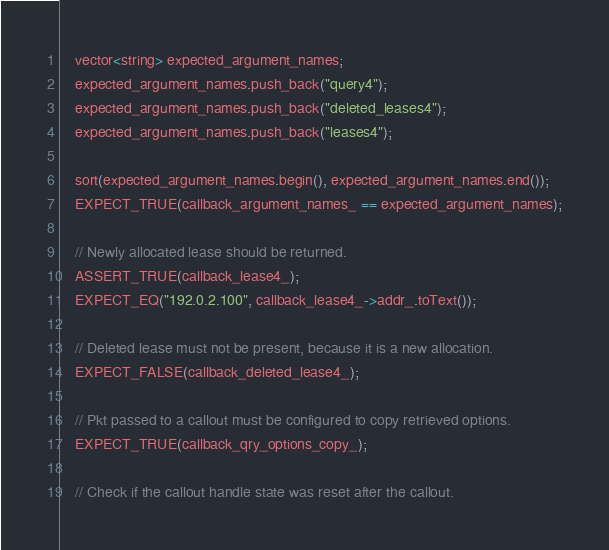Convert code to text. <code><loc_0><loc_0><loc_500><loc_500><_C++_>    vector<string> expected_argument_names;
    expected_argument_names.push_back("query4");
    expected_argument_names.push_back("deleted_leases4");
    expected_argument_names.push_back("leases4");

    sort(expected_argument_names.begin(), expected_argument_names.end());
    EXPECT_TRUE(callback_argument_names_ == expected_argument_names);

    // Newly allocated lease should be returned.
    ASSERT_TRUE(callback_lease4_);
    EXPECT_EQ("192.0.2.100", callback_lease4_->addr_.toText());

    // Deleted lease must not be present, because it is a new allocation.
    EXPECT_FALSE(callback_deleted_lease4_);

    // Pkt passed to a callout must be configured to copy retrieved options.
    EXPECT_TRUE(callback_qry_options_copy_);

    // Check if the callout handle state was reset after the callout.</code> 